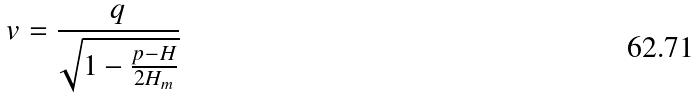Convert formula to latex. <formula><loc_0><loc_0><loc_500><loc_500>v = \frac { q } { \sqrt { 1 - \frac { p - H } { 2 H _ { m } } } }</formula> 